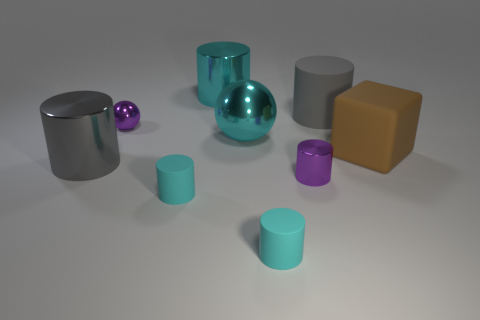How big is the cyan cylinder behind the block?
Your answer should be compact. Large. Does the large sphere have the same material as the purple ball?
Keep it short and to the point. Yes. How many purple things are the same size as the gray metal thing?
Keep it short and to the point. 0. Are there an equal number of gray metallic objects that are to the right of the large brown thing and purple metal things?
Your answer should be very brief. No. How many tiny things are behind the purple cylinder and to the right of the purple metallic sphere?
Keep it short and to the point. 0. Does the gray object that is behind the small sphere have the same shape as the big gray shiny thing?
Give a very brief answer. Yes. There is a sphere that is the same size as the brown thing; what is it made of?
Offer a terse response. Metal. Are there the same number of small matte cylinders on the right side of the purple cylinder and large cyan shiny cylinders that are right of the big brown block?
Provide a succinct answer. Yes. How many small rubber cylinders are to the right of the small purple thing that is in front of the tiny thing behind the large gray metal cylinder?
Offer a very short reply. 0. There is a tiny shiny sphere; is it the same color as the tiny metal object that is right of the cyan metallic sphere?
Make the answer very short. Yes. 